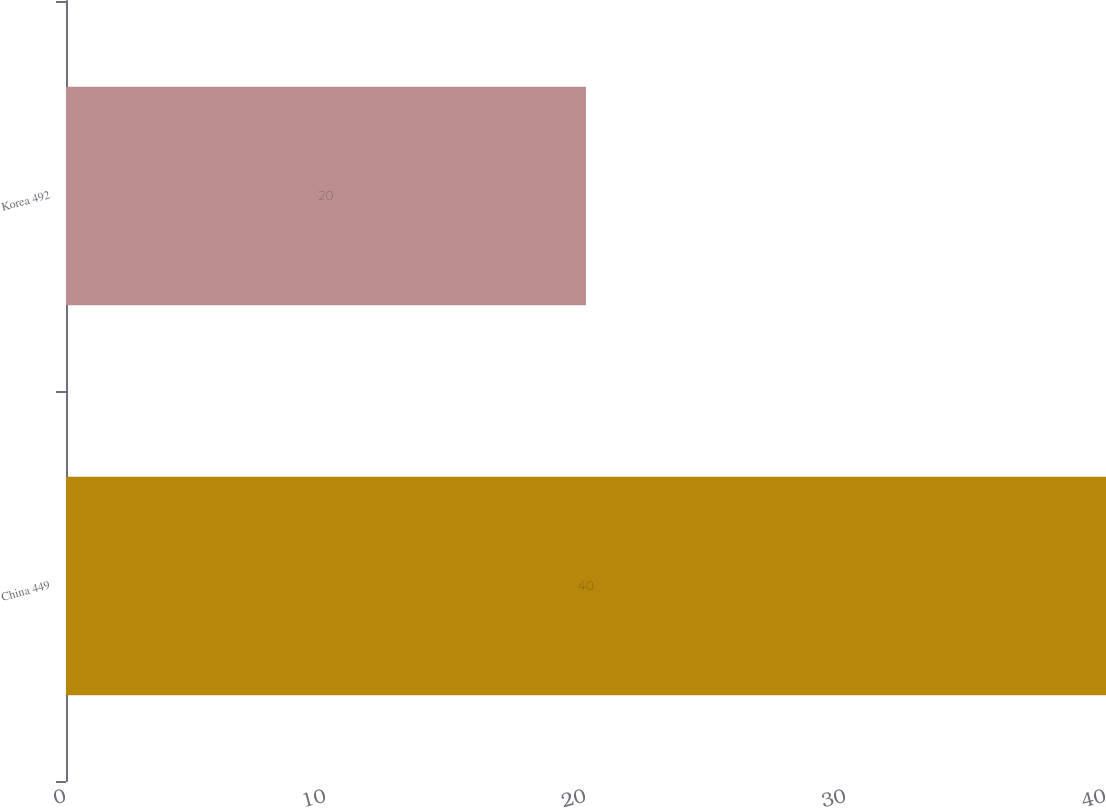<chart> <loc_0><loc_0><loc_500><loc_500><bar_chart><fcel>China 449<fcel>Korea 492<nl><fcel>40<fcel>20<nl></chart> 